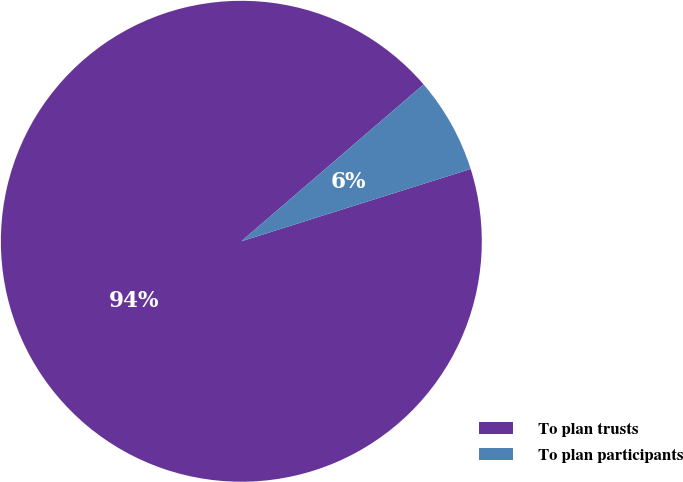<chart> <loc_0><loc_0><loc_500><loc_500><pie_chart><fcel>To plan trusts<fcel>To plan participants<nl><fcel>93.55%<fcel>6.45%<nl></chart> 